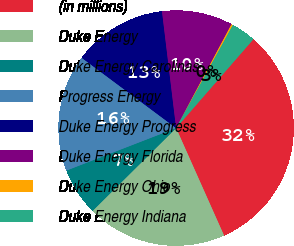Convert chart. <chart><loc_0><loc_0><loc_500><loc_500><pie_chart><fcel>(in millions)<fcel>Duke Energy<fcel>Duke Energy Carolinas<fcel>Progress Energy<fcel>Duke Energy Progress<fcel>Duke Energy Florida<fcel>Duke Energy Ohio<fcel>Duke Energy Indiana<nl><fcel>31.93%<fcel>19.24%<fcel>6.55%<fcel>16.07%<fcel>12.9%<fcel>9.72%<fcel>0.21%<fcel>3.38%<nl></chart> 